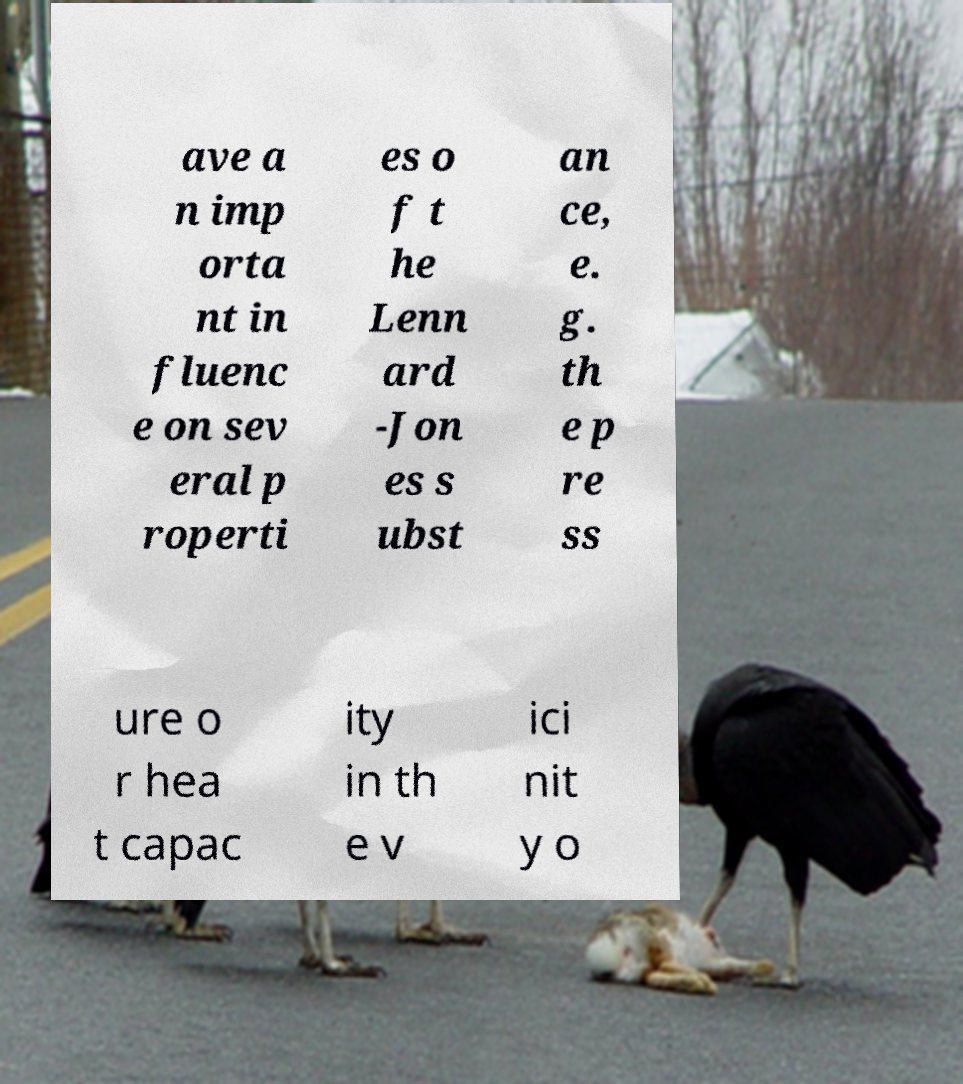Could you extract and type out the text from this image? ave a n imp orta nt in fluenc e on sev eral p roperti es o f t he Lenn ard -Jon es s ubst an ce, e. g. th e p re ss ure o r hea t capac ity in th e v ici nit y o 